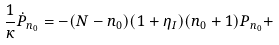Convert formula to latex. <formula><loc_0><loc_0><loc_500><loc_500>\frac { 1 } { \kappa } \dot { P } _ { n _ { 0 } } = - ( N - n _ { 0 } ) ( 1 + \eta _ { I } ) ( n _ { 0 } + 1 ) P _ { n _ { 0 } } +</formula> 